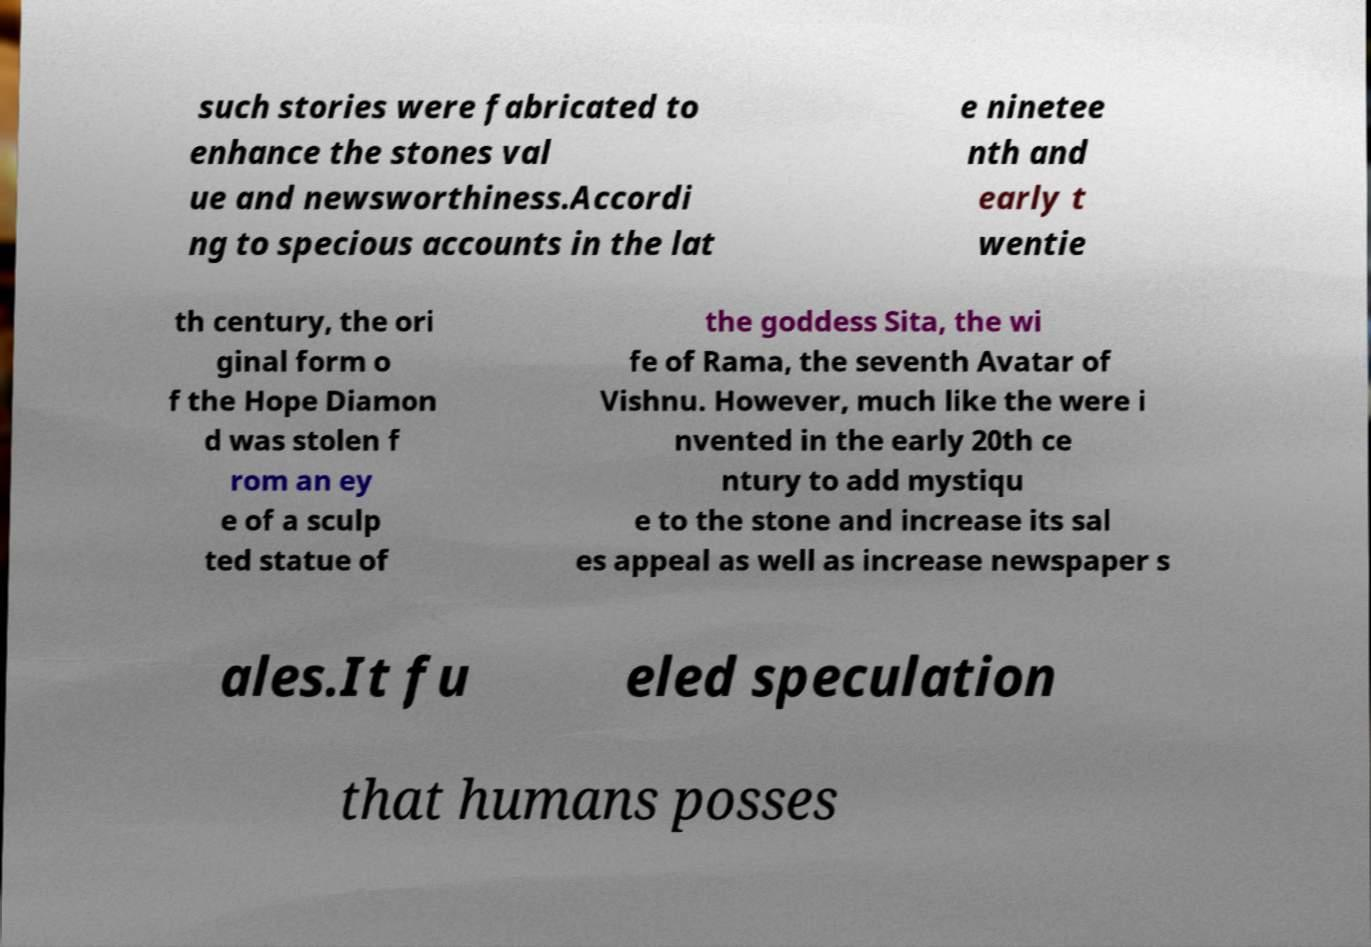Could you assist in decoding the text presented in this image and type it out clearly? such stories were fabricated to enhance the stones val ue and newsworthiness.Accordi ng to specious accounts in the lat e ninetee nth and early t wentie th century, the ori ginal form o f the Hope Diamon d was stolen f rom an ey e of a sculp ted statue of the goddess Sita, the wi fe of Rama, the seventh Avatar of Vishnu. However, much like the were i nvented in the early 20th ce ntury to add mystiqu e to the stone and increase its sal es appeal as well as increase newspaper s ales.It fu eled speculation that humans posses 